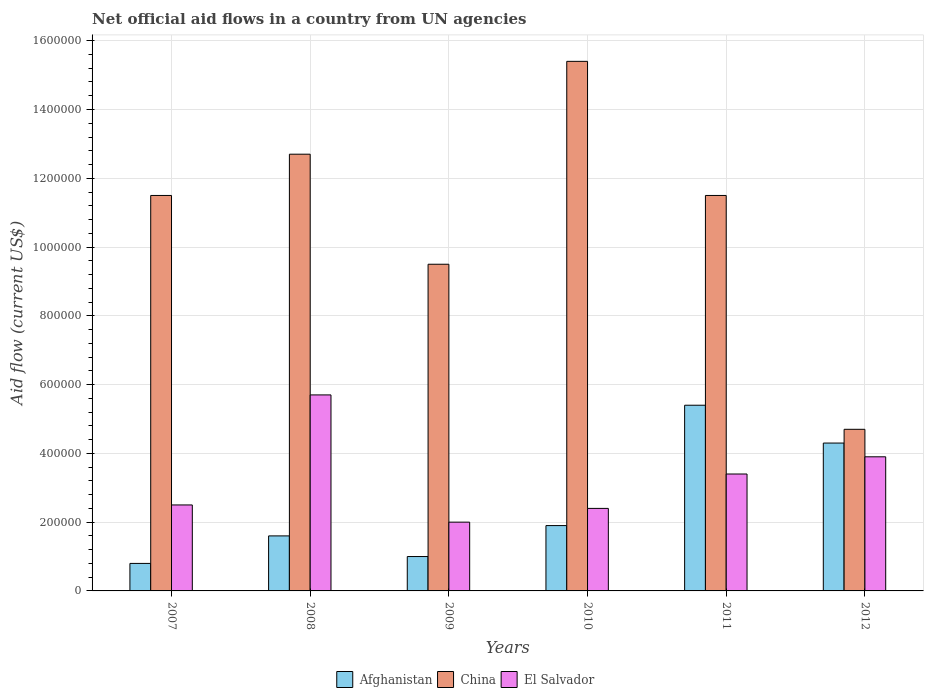Are the number of bars per tick equal to the number of legend labels?
Make the answer very short. Yes. Are the number of bars on each tick of the X-axis equal?
Offer a very short reply. Yes. How many bars are there on the 4th tick from the left?
Give a very brief answer. 3. What is the label of the 4th group of bars from the left?
Make the answer very short. 2010. What is the net official aid flow in El Salvador in 2009?
Give a very brief answer. 2.00e+05. Across all years, what is the maximum net official aid flow in El Salvador?
Offer a very short reply. 5.70e+05. Across all years, what is the minimum net official aid flow in China?
Provide a succinct answer. 4.70e+05. What is the total net official aid flow in China in the graph?
Your answer should be very brief. 6.53e+06. What is the difference between the net official aid flow in Afghanistan in 2007 and that in 2011?
Give a very brief answer. -4.60e+05. What is the difference between the net official aid flow in El Salvador in 2008 and the net official aid flow in China in 2011?
Make the answer very short. -5.80e+05. What is the average net official aid flow in El Salvador per year?
Your answer should be compact. 3.32e+05. In the year 2009, what is the difference between the net official aid flow in China and net official aid flow in Afghanistan?
Your answer should be very brief. 8.50e+05. In how many years, is the net official aid flow in El Salvador greater than 1280000 US$?
Your answer should be very brief. 0. What is the difference between the highest and the lowest net official aid flow in Afghanistan?
Ensure brevity in your answer.  4.60e+05. What does the 1st bar from the left in 2007 represents?
Offer a terse response. Afghanistan. What does the 1st bar from the right in 2009 represents?
Provide a succinct answer. El Salvador. Is it the case that in every year, the sum of the net official aid flow in El Salvador and net official aid flow in Afghanistan is greater than the net official aid flow in China?
Ensure brevity in your answer.  No. Are the values on the major ticks of Y-axis written in scientific E-notation?
Your answer should be very brief. No. Does the graph contain grids?
Keep it short and to the point. Yes. How are the legend labels stacked?
Offer a terse response. Horizontal. What is the title of the graph?
Provide a short and direct response. Net official aid flows in a country from UN agencies. What is the label or title of the Y-axis?
Your answer should be compact. Aid flow (current US$). What is the Aid flow (current US$) of China in 2007?
Offer a very short reply. 1.15e+06. What is the Aid flow (current US$) in Afghanistan in 2008?
Your answer should be very brief. 1.60e+05. What is the Aid flow (current US$) in China in 2008?
Keep it short and to the point. 1.27e+06. What is the Aid flow (current US$) of El Salvador in 2008?
Give a very brief answer. 5.70e+05. What is the Aid flow (current US$) in Afghanistan in 2009?
Ensure brevity in your answer.  1.00e+05. What is the Aid flow (current US$) of China in 2009?
Your response must be concise. 9.50e+05. What is the Aid flow (current US$) in Afghanistan in 2010?
Provide a short and direct response. 1.90e+05. What is the Aid flow (current US$) of China in 2010?
Your answer should be compact. 1.54e+06. What is the Aid flow (current US$) of Afghanistan in 2011?
Keep it short and to the point. 5.40e+05. What is the Aid flow (current US$) in China in 2011?
Make the answer very short. 1.15e+06. What is the Aid flow (current US$) of El Salvador in 2012?
Offer a terse response. 3.90e+05. Across all years, what is the maximum Aid flow (current US$) of Afghanistan?
Offer a terse response. 5.40e+05. Across all years, what is the maximum Aid flow (current US$) in China?
Provide a short and direct response. 1.54e+06. Across all years, what is the maximum Aid flow (current US$) of El Salvador?
Provide a short and direct response. 5.70e+05. Across all years, what is the minimum Aid flow (current US$) of Afghanistan?
Give a very brief answer. 8.00e+04. Across all years, what is the minimum Aid flow (current US$) in China?
Give a very brief answer. 4.70e+05. What is the total Aid flow (current US$) in Afghanistan in the graph?
Provide a succinct answer. 1.50e+06. What is the total Aid flow (current US$) of China in the graph?
Provide a succinct answer. 6.53e+06. What is the total Aid flow (current US$) in El Salvador in the graph?
Offer a very short reply. 1.99e+06. What is the difference between the Aid flow (current US$) of El Salvador in 2007 and that in 2008?
Your answer should be very brief. -3.20e+05. What is the difference between the Aid flow (current US$) of Afghanistan in 2007 and that in 2009?
Provide a succinct answer. -2.00e+04. What is the difference between the Aid flow (current US$) in China in 2007 and that in 2009?
Ensure brevity in your answer.  2.00e+05. What is the difference between the Aid flow (current US$) in China in 2007 and that in 2010?
Your answer should be very brief. -3.90e+05. What is the difference between the Aid flow (current US$) in El Salvador in 2007 and that in 2010?
Offer a very short reply. 10000. What is the difference between the Aid flow (current US$) in Afghanistan in 2007 and that in 2011?
Make the answer very short. -4.60e+05. What is the difference between the Aid flow (current US$) in China in 2007 and that in 2011?
Provide a short and direct response. 0. What is the difference between the Aid flow (current US$) of Afghanistan in 2007 and that in 2012?
Your answer should be compact. -3.50e+05. What is the difference between the Aid flow (current US$) in China in 2007 and that in 2012?
Offer a very short reply. 6.80e+05. What is the difference between the Aid flow (current US$) in China in 2008 and that in 2009?
Give a very brief answer. 3.20e+05. What is the difference between the Aid flow (current US$) in El Salvador in 2008 and that in 2009?
Your answer should be very brief. 3.70e+05. What is the difference between the Aid flow (current US$) of China in 2008 and that in 2010?
Make the answer very short. -2.70e+05. What is the difference between the Aid flow (current US$) in El Salvador in 2008 and that in 2010?
Ensure brevity in your answer.  3.30e+05. What is the difference between the Aid flow (current US$) in Afghanistan in 2008 and that in 2011?
Keep it short and to the point. -3.80e+05. What is the difference between the Aid flow (current US$) in China in 2008 and that in 2011?
Ensure brevity in your answer.  1.20e+05. What is the difference between the Aid flow (current US$) of El Salvador in 2008 and that in 2011?
Provide a succinct answer. 2.30e+05. What is the difference between the Aid flow (current US$) of El Salvador in 2008 and that in 2012?
Keep it short and to the point. 1.80e+05. What is the difference between the Aid flow (current US$) in Afghanistan in 2009 and that in 2010?
Provide a short and direct response. -9.00e+04. What is the difference between the Aid flow (current US$) in China in 2009 and that in 2010?
Ensure brevity in your answer.  -5.90e+05. What is the difference between the Aid flow (current US$) of El Salvador in 2009 and that in 2010?
Your response must be concise. -4.00e+04. What is the difference between the Aid flow (current US$) of Afghanistan in 2009 and that in 2011?
Your answer should be very brief. -4.40e+05. What is the difference between the Aid flow (current US$) in China in 2009 and that in 2011?
Your answer should be very brief. -2.00e+05. What is the difference between the Aid flow (current US$) of El Salvador in 2009 and that in 2011?
Your answer should be very brief. -1.40e+05. What is the difference between the Aid flow (current US$) in Afghanistan in 2009 and that in 2012?
Offer a terse response. -3.30e+05. What is the difference between the Aid flow (current US$) of China in 2009 and that in 2012?
Make the answer very short. 4.80e+05. What is the difference between the Aid flow (current US$) of El Salvador in 2009 and that in 2012?
Offer a terse response. -1.90e+05. What is the difference between the Aid flow (current US$) in Afghanistan in 2010 and that in 2011?
Ensure brevity in your answer.  -3.50e+05. What is the difference between the Aid flow (current US$) in China in 2010 and that in 2011?
Provide a short and direct response. 3.90e+05. What is the difference between the Aid flow (current US$) of El Salvador in 2010 and that in 2011?
Offer a terse response. -1.00e+05. What is the difference between the Aid flow (current US$) in Afghanistan in 2010 and that in 2012?
Make the answer very short. -2.40e+05. What is the difference between the Aid flow (current US$) in China in 2010 and that in 2012?
Offer a very short reply. 1.07e+06. What is the difference between the Aid flow (current US$) in Afghanistan in 2011 and that in 2012?
Offer a very short reply. 1.10e+05. What is the difference between the Aid flow (current US$) of China in 2011 and that in 2012?
Provide a short and direct response. 6.80e+05. What is the difference between the Aid flow (current US$) of Afghanistan in 2007 and the Aid flow (current US$) of China in 2008?
Give a very brief answer. -1.19e+06. What is the difference between the Aid flow (current US$) in Afghanistan in 2007 and the Aid flow (current US$) in El Salvador in 2008?
Keep it short and to the point. -4.90e+05. What is the difference between the Aid flow (current US$) in China in 2007 and the Aid flow (current US$) in El Salvador in 2008?
Provide a short and direct response. 5.80e+05. What is the difference between the Aid flow (current US$) in Afghanistan in 2007 and the Aid flow (current US$) in China in 2009?
Keep it short and to the point. -8.70e+05. What is the difference between the Aid flow (current US$) of China in 2007 and the Aid flow (current US$) of El Salvador in 2009?
Offer a very short reply. 9.50e+05. What is the difference between the Aid flow (current US$) in Afghanistan in 2007 and the Aid flow (current US$) in China in 2010?
Provide a succinct answer. -1.46e+06. What is the difference between the Aid flow (current US$) in Afghanistan in 2007 and the Aid flow (current US$) in El Salvador in 2010?
Offer a very short reply. -1.60e+05. What is the difference between the Aid flow (current US$) in China in 2007 and the Aid flow (current US$) in El Salvador in 2010?
Keep it short and to the point. 9.10e+05. What is the difference between the Aid flow (current US$) in Afghanistan in 2007 and the Aid flow (current US$) in China in 2011?
Offer a very short reply. -1.07e+06. What is the difference between the Aid flow (current US$) in Afghanistan in 2007 and the Aid flow (current US$) in El Salvador in 2011?
Provide a succinct answer. -2.60e+05. What is the difference between the Aid flow (current US$) of China in 2007 and the Aid flow (current US$) of El Salvador in 2011?
Your response must be concise. 8.10e+05. What is the difference between the Aid flow (current US$) in Afghanistan in 2007 and the Aid flow (current US$) in China in 2012?
Your response must be concise. -3.90e+05. What is the difference between the Aid flow (current US$) in Afghanistan in 2007 and the Aid flow (current US$) in El Salvador in 2012?
Make the answer very short. -3.10e+05. What is the difference between the Aid flow (current US$) of China in 2007 and the Aid flow (current US$) of El Salvador in 2012?
Your answer should be compact. 7.60e+05. What is the difference between the Aid flow (current US$) of Afghanistan in 2008 and the Aid flow (current US$) of China in 2009?
Provide a succinct answer. -7.90e+05. What is the difference between the Aid flow (current US$) in Afghanistan in 2008 and the Aid flow (current US$) in El Salvador in 2009?
Your response must be concise. -4.00e+04. What is the difference between the Aid flow (current US$) of China in 2008 and the Aid flow (current US$) of El Salvador in 2009?
Your answer should be compact. 1.07e+06. What is the difference between the Aid flow (current US$) of Afghanistan in 2008 and the Aid flow (current US$) of China in 2010?
Offer a very short reply. -1.38e+06. What is the difference between the Aid flow (current US$) of China in 2008 and the Aid flow (current US$) of El Salvador in 2010?
Give a very brief answer. 1.03e+06. What is the difference between the Aid flow (current US$) of Afghanistan in 2008 and the Aid flow (current US$) of China in 2011?
Your answer should be compact. -9.90e+05. What is the difference between the Aid flow (current US$) in China in 2008 and the Aid flow (current US$) in El Salvador in 2011?
Keep it short and to the point. 9.30e+05. What is the difference between the Aid flow (current US$) of Afghanistan in 2008 and the Aid flow (current US$) of China in 2012?
Offer a very short reply. -3.10e+05. What is the difference between the Aid flow (current US$) in Afghanistan in 2008 and the Aid flow (current US$) in El Salvador in 2012?
Offer a very short reply. -2.30e+05. What is the difference between the Aid flow (current US$) in China in 2008 and the Aid flow (current US$) in El Salvador in 2012?
Your answer should be very brief. 8.80e+05. What is the difference between the Aid flow (current US$) in Afghanistan in 2009 and the Aid flow (current US$) in China in 2010?
Your answer should be very brief. -1.44e+06. What is the difference between the Aid flow (current US$) of Afghanistan in 2009 and the Aid flow (current US$) of El Salvador in 2010?
Keep it short and to the point. -1.40e+05. What is the difference between the Aid flow (current US$) of China in 2009 and the Aid flow (current US$) of El Salvador in 2010?
Provide a short and direct response. 7.10e+05. What is the difference between the Aid flow (current US$) in Afghanistan in 2009 and the Aid flow (current US$) in China in 2011?
Keep it short and to the point. -1.05e+06. What is the difference between the Aid flow (current US$) of Afghanistan in 2009 and the Aid flow (current US$) of El Salvador in 2011?
Ensure brevity in your answer.  -2.40e+05. What is the difference between the Aid flow (current US$) of Afghanistan in 2009 and the Aid flow (current US$) of China in 2012?
Your answer should be compact. -3.70e+05. What is the difference between the Aid flow (current US$) of Afghanistan in 2009 and the Aid flow (current US$) of El Salvador in 2012?
Your answer should be compact. -2.90e+05. What is the difference between the Aid flow (current US$) in China in 2009 and the Aid flow (current US$) in El Salvador in 2012?
Keep it short and to the point. 5.60e+05. What is the difference between the Aid flow (current US$) of Afghanistan in 2010 and the Aid flow (current US$) of China in 2011?
Give a very brief answer. -9.60e+05. What is the difference between the Aid flow (current US$) of Afghanistan in 2010 and the Aid flow (current US$) of El Salvador in 2011?
Offer a very short reply. -1.50e+05. What is the difference between the Aid flow (current US$) of China in 2010 and the Aid flow (current US$) of El Salvador in 2011?
Offer a very short reply. 1.20e+06. What is the difference between the Aid flow (current US$) in Afghanistan in 2010 and the Aid flow (current US$) in China in 2012?
Provide a short and direct response. -2.80e+05. What is the difference between the Aid flow (current US$) of Afghanistan in 2010 and the Aid flow (current US$) of El Salvador in 2012?
Your response must be concise. -2.00e+05. What is the difference between the Aid flow (current US$) of China in 2010 and the Aid flow (current US$) of El Salvador in 2012?
Your answer should be compact. 1.15e+06. What is the difference between the Aid flow (current US$) of Afghanistan in 2011 and the Aid flow (current US$) of China in 2012?
Ensure brevity in your answer.  7.00e+04. What is the difference between the Aid flow (current US$) of Afghanistan in 2011 and the Aid flow (current US$) of El Salvador in 2012?
Your response must be concise. 1.50e+05. What is the difference between the Aid flow (current US$) in China in 2011 and the Aid flow (current US$) in El Salvador in 2012?
Keep it short and to the point. 7.60e+05. What is the average Aid flow (current US$) in Afghanistan per year?
Provide a short and direct response. 2.50e+05. What is the average Aid flow (current US$) in China per year?
Keep it short and to the point. 1.09e+06. What is the average Aid flow (current US$) in El Salvador per year?
Your answer should be compact. 3.32e+05. In the year 2007, what is the difference between the Aid flow (current US$) in Afghanistan and Aid flow (current US$) in China?
Provide a short and direct response. -1.07e+06. In the year 2007, what is the difference between the Aid flow (current US$) in Afghanistan and Aid flow (current US$) in El Salvador?
Keep it short and to the point. -1.70e+05. In the year 2008, what is the difference between the Aid flow (current US$) of Afghanistan and Aid flow (current US$) of China?
Provide a short and direct response. -1.11e+06. In the year 2008, what is the difference between the Aid flow (current US$) of Afghanistan and Aid flow (current US$) of El Salvador?
Make the answer very short. -4.10e+05. In the year 2008, what is the difference between the Aid flow (current US$) in China and Aid flow (current US$) in El Salvador?
Your answer should be very brief. 7.00e+05. In the year 2009, what is the difference between the Aid flow (current US$) of Afghanistan and Aid flow (current US$) of China?
Give a very brief answer. -8.50e+05. In the year 2009, what is the difference between the Aid flow (current US$) in China and Aid flow (current US$) in El Salvador?
Offer a terse response. 7.50e+05. In the year 2010, what is the difference between the Aid flow (current US$) in Afghanistan and Aid flow (current US$) in China?
Your answer should be very brief. -1.35e+06. In the year 2010, what is the difference between the Aid flow (current US$) in Afghanistan and Aid flow (current US$) in El Salvador?
Your response must be concise. -5.00e+04. In the year 2010, what is the difference between the Aid flow (current US$) of China and Aid flow (current US$) of El Salvador?
Your answer should be very brief. 1.30e+06. In the year 2011, what is the difference between the Aid flow (current US$) of Afghanistan and Aid flow (current US$) of China?
Offer a very short reply. -6.10e+05. In the year 2011, what is the difference between the Aid flow (current US$) in Afghanistan and Aid flow (current US$) in El Salvador?
Make the answer very short. 2.00e+05. In the year 2011, what is the difference between the Aid flow (current US$) in China and Aid flow (current US$) in El Salvador?
Provide a short and direct response. 8.10e+05. In the year 2012, what is the difference between the Aid flow (current US$) of Afghanistan and Aid flow (current US$) of El Salvador?
Make the answer very short. 4.00e+04. In the year 2012, what is the difference between the Aid flow (current US$) in China and Aid flow (current US$) in El Salvador?
Offer a terse response. 8.00e+04. What is the ratio of the Aid flow (current US$) in China in 2007 to that in 2008?
Give a very brief answer. 0.91. What is the ratio of the Aid flow (current US$) in El Salvador in 2007 to that in 2008?
Ensure brevity in your answer.  0.44. What is the ratio of the Aid flow (current US$) in Afghanistan in 2007 to that in 2009?
Give a very brief answer. 0.8. What is the ratio of the Aid flow (current US$) of China in 2007 to that in 2009?
Provide a succinct answer. 1.21. What is the ratio of the Aid flow (current US$) in El Salvador in 2007 to that in 2009?
Your answer should be very brief. 1.25. What is the ratio of the Aid flow (current US$) in Afghanistan in 2007 to that in 2010?
Keep it short and to the point. 0.42. What is the ratio of the Aid flow (current US$) in China in 2007 to that in 2010?
Offer a very short reply. 0.75. What is the ratio of the Aid flow (current US$) in El Salvador in 2007 to that in 2010?
Offer a very short reply. 1.04. What is the ratio of the Aid flow (current US$) of Afghanistan in 2007 to that in 2011?
Provide a short and direct response. 0.15. What is the ratio of the Aid flow (current US$) in El Salvador in 2007 to that in 2011?
Give a very brief answer. 0.74. What is the ratio of the Aid flow (current US$) of Afghanistan in 2007 to that in 2012?
Your response must be concise. 0.19. What is the ratio of the Aid flow (current US$) of China in 2007 to that in 2012?
Provide a succinct answer. 2.45. What is the ratio of the Aid flow (current US$) in El Salvador in 2007 to that in 2012?
Make the answer very short. 0.64. What is the ratio of the Aid flow (current US$) in China in 2008 to that in 2009?
Make the answer very short. 1.34. What is the ratio of the Aid flow (current US$) in El Salvador in 2008 to that in 2009?
Offer a very short reply. 2.85. What is the ratio of the Aid flow (current US$) in Afghanistan in 2008 to that in 2010?
Your answer should be compact. 0.84. What is the ratio of the Aid flow (current US$) in China in 2008 to that in 2010?
Ensure brevity in your answer.  0.82. What is the ratio of the Aid flow (current US$) of El Salvador in 2008 to that in 2010?
Make the answer very short. 2.38. What is the ratio of the Aid flow (current US$) in Afghanistan in 2008 to that in 2011?
Offer a very short reply. 0.3. What is the ratio of the Aid flow (current US$) of China in 2008 to that in 2011?
Ensure brevity in your answer.  1.1. What is the ratio of the Aid flow (current US$) of El Salvador in 2008 to that in 2011?
Your response must be concise. 1.68. What is the ratio of the Aid flow (current US$) of Afghanistan in 2008 to that in 2012?
Keep it short and to the point. 0.37. What is the ratio of the Aid flow (current US$) in China in 2008 to that in 2012?
Offer a very short reply. 2.7. What is the ratio of the Aid flow (current US$) in El Salvador in 2008 to that in 2012?
Give a very brief answer. 1.46. What is the ratio of the Aid flow (current US$) of Afghanistan in 2009 to that in 2010?
Your answer should be very brief. 0.53. What is the ratio of the Aid flow (current US$) of China in 2009 to that in 2010?
Your answer should be compact. 0.62. What is the ratio of the Aid flow (current US$) of El Salvador in 2009 to that in 2010?
Your answer should be compact. 0.83. What is the ratio of the Aid flow (current US$) in Afghanistan in 2009 to that in 2011?
Give a very brief answer. 0.19. What is the ratio of the Aid flow (current US$) of China in 2009 to that in 2011?
Offer a terse response. 0.83. What is the ratio of the Aid flow (current US$) of El Salvador in 2009 to that in 2011?
Give a very brief answer. 0.59. What is the ratio of the Aid flow (current US$) of Afghanistan in 2009 to that in 2012?
Keep it short and to the point. 0.23. What is the ratio of the Aid flow (current US$) in China in 2009 to that in 2012?
Make the answer very short. 2.02. What is the ratio of the Aid flow (current US$) of El Salvador in 2009 to that in 2012?
Keep it short and to the point. 0.51. What is the ratio of the Aid flow (current US$) in Afghanistan in 2010 to that in 2011?
Offer a terse response. 0.35. What is the ratio of the Aid flow (current US$) in China in 2010 to that in 2011?
Make the answer very short. 1.34. What is the ratio of the Aid flow (current US$) of El Salvador in 2010 to that in 2011?
Your answer should be very brief. 0.71. What is the ratio of the Aid flow (current US$) of Afghanistan in 2010 to that in 2012?
Your answer should be very brief. 0.44. What is the ratio of the Aid flow (current US$) in China in 2010 to that in 2012?
Your answer should be very brief. 3.28. What is the ratio of the Aid flow (current US$) of El Salvador in 2010 to that in 2012?
Provide a short and direct response. 0.62. What is the ratio of the Aid flow (current US$) of Afghanistan in 2011 to that in 2012?
Your response must be concise. 1.26. What is the ratio of the Aid flow (current US$) in China in 2011 to that in 2012?
Your answer should be compact. 2.45. What is the ratio of the Aid flow (current US$) of El Salvador in 2011 to that in 2012?
Offer a very short reply. 0.87. What is the difference between the highest and the second highest Aid flow (current US$) of Afghanistan?
Provide a succinct answer. 1.10e+05. What is the difference between the highest and the second highest Aid flow (current US$) of China?
Offer a very short reply. 2.70e+05. What is the difference between the highest and the second highest Aid flow (current US$) in El Salvador?
Offer a terse response. 1.80e+05. What is the difference between the highest and the lowest Aid flow (current US$) in Afghanistan?
Give a very brief answer. 4.60e+05. What is the difference between the highest and the lowest Aid flow (current US$) in China?
Your response must be concise. 1.07e+06. 